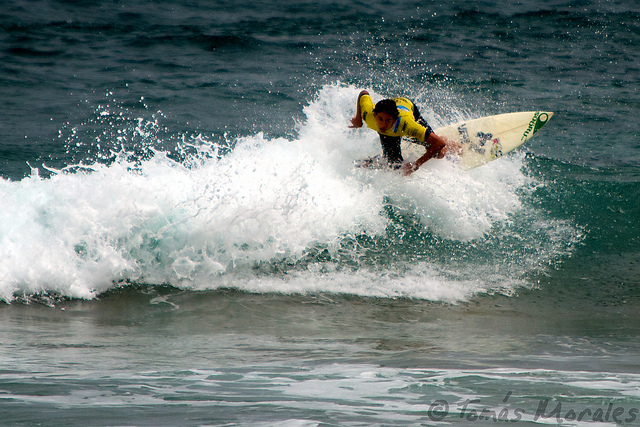Extract all visible text content from this image. Tomas Morales 